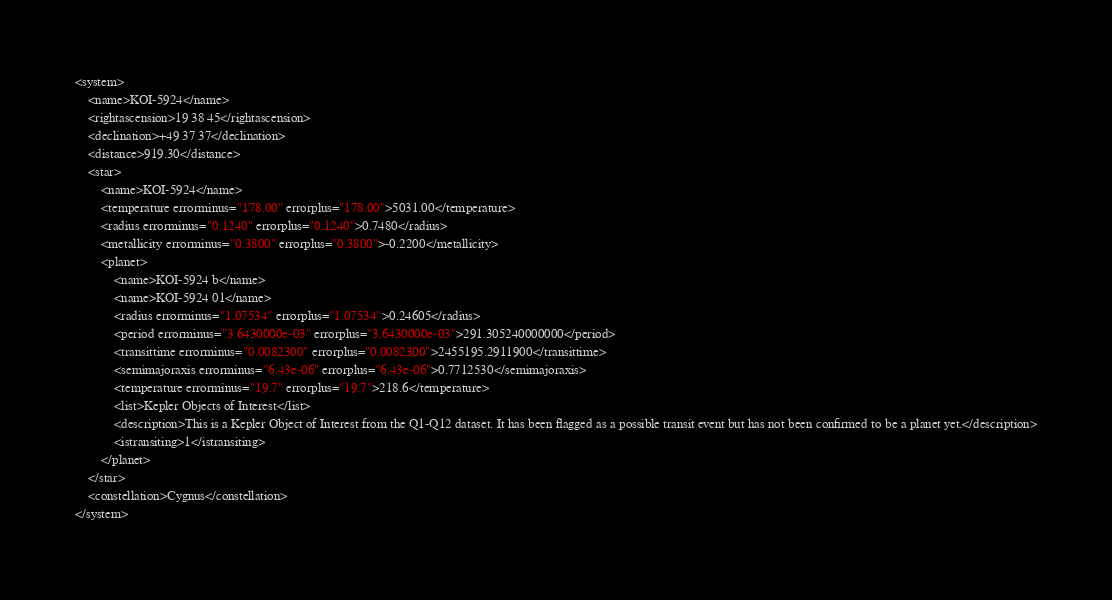Convert code to text. <code><loc_0><loc_0><loc_500><loc_500><_XML_><system>
	<name>KOI-5924</name>
	<rightascension>19 38 45</rightascension>
	<declination>+49 37 37</declination>
	<distance>919.30</distance>
	<star>
		<name>KOI-5924</name>
		<temperature errorminus="178.00" errorplus="178.00">5031.00</temperature>
		<radius errorminus="0.1240" errorplus="0.1240">0.7480</radius>
		<metallicity errorminus="0.3800" errorplus="0.3800">-0.2200</metallicity>
		<planet>
			<name>KOI-5924 b</name>
			<name>KOI-5924 01</name>
			<radius errorminus="1.07534" errorplus="1.07534">0.24605</radius>
			<period errorminus="3.6430000e-03" errorplus="3.6430000e-03">291.305240000000</period>
			<transittime errorminus="0.0082300" errorplus="0.0082300">2455195.2911900</transittime>
			<semimajoraxis errorminus="6.43e-06" errorplus="6.43e-06">0.7712530</semimajoraxis>
			<temperature errorminus="19.7" errorplus="19.7">218.6</temperature>
			<list>Kepler Objects of Interest</list>
			<description>This is a Kepler Object of Interest from the Q1-Q12 dataset. It has been flagged as a possible transit event but has not been confirmed to be a planet yet.</description>
			<istransiting>1</istransiting>
		</planet>
	</star>
	<constellation>Cygnus</constellation>
</system>
</code> 